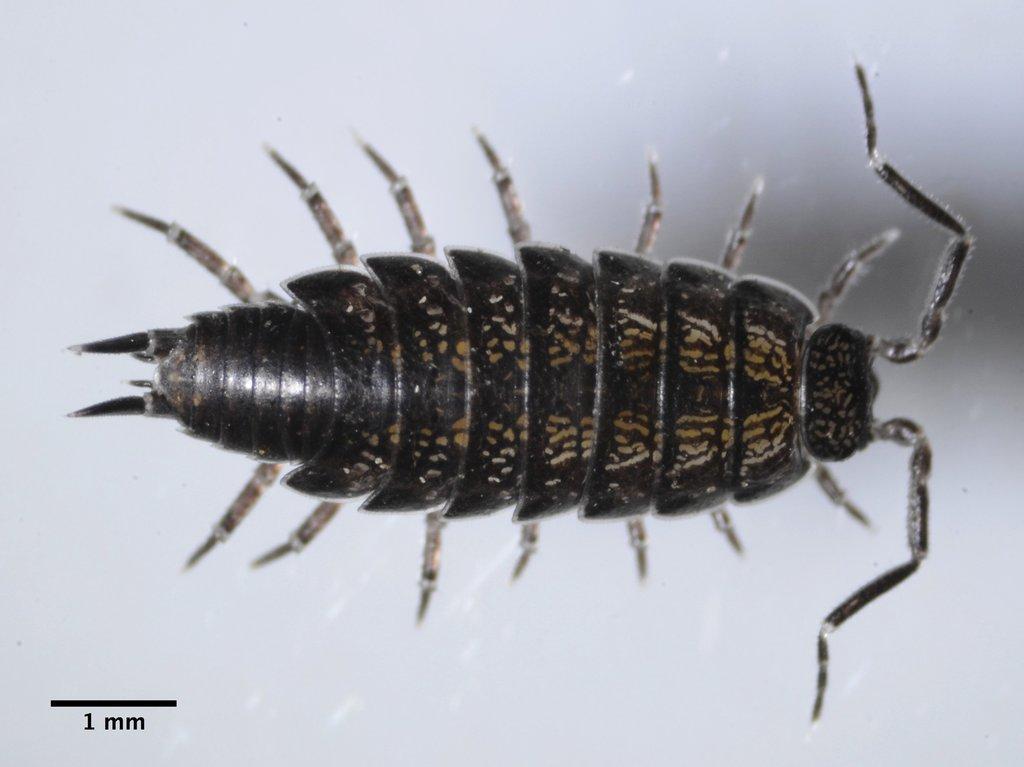Can you describe this image briefly? In this image there is an insect. In the bottom left there is text on the image. The background is white. 